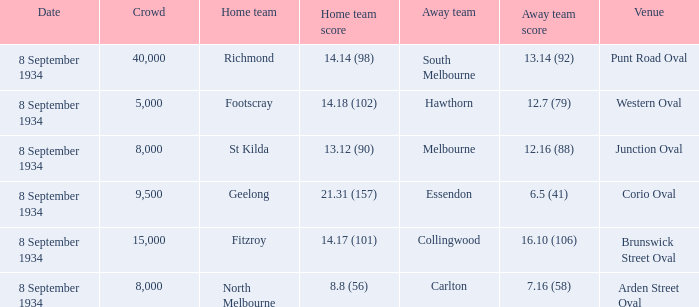When the Venue was Punt Road Oval, who was the Home Team? Richmond. 